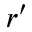<formula> <loc_0><loc_0><loc_500><loc_500>r ^ { \prime }</formula> 